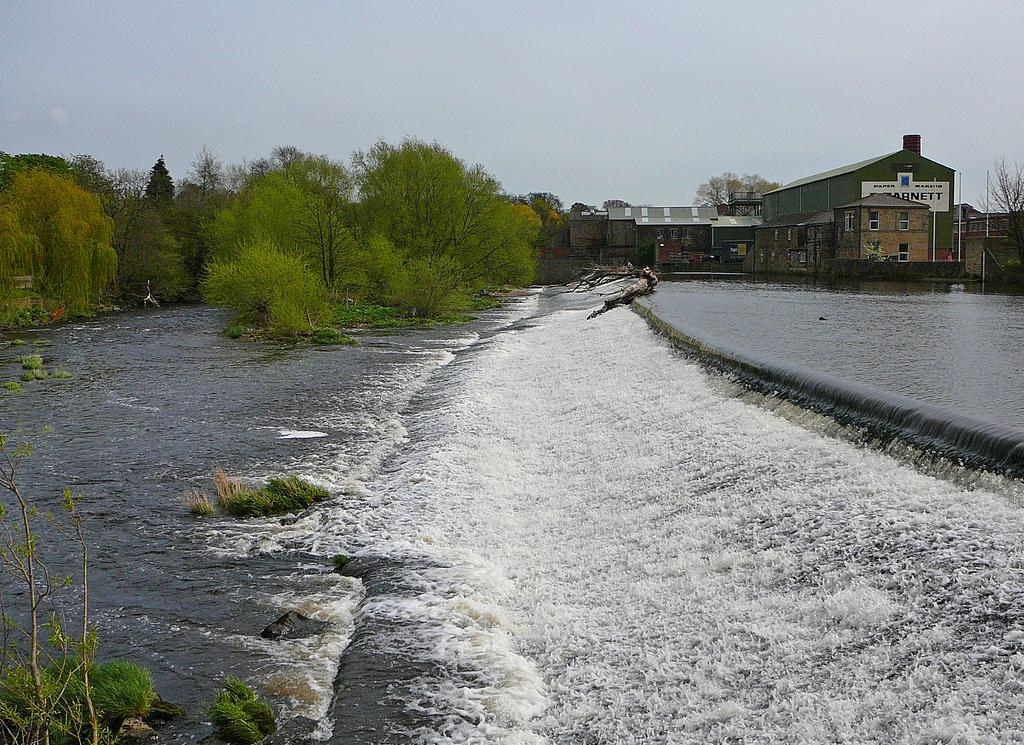Can you describe this image briefly? In this picture I can see some buildings, trees and I can see the water flow. 